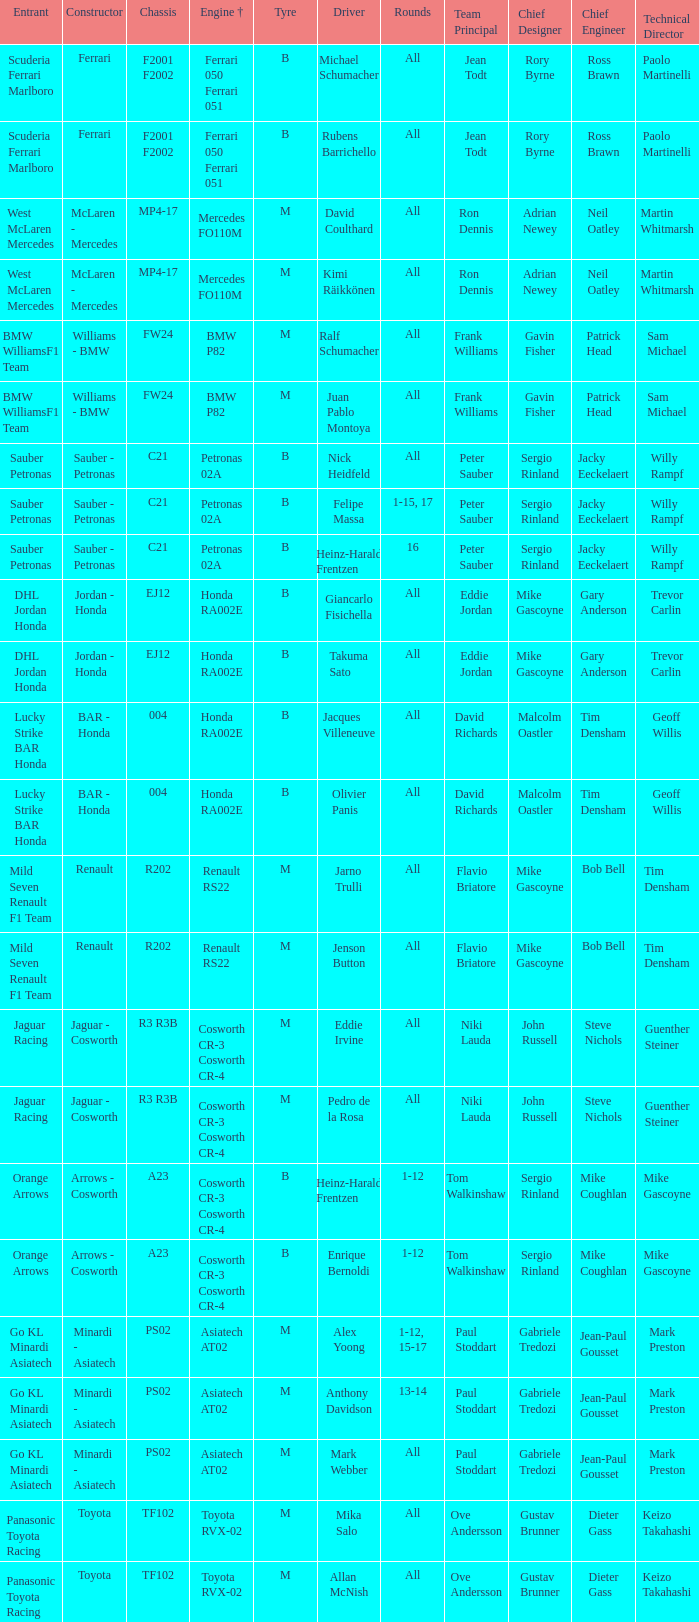What is the chassis when the tyre is b, the engine is ferrari 050 ferrari 051 and the driver is rubens barrichello? F2001 F2002. 